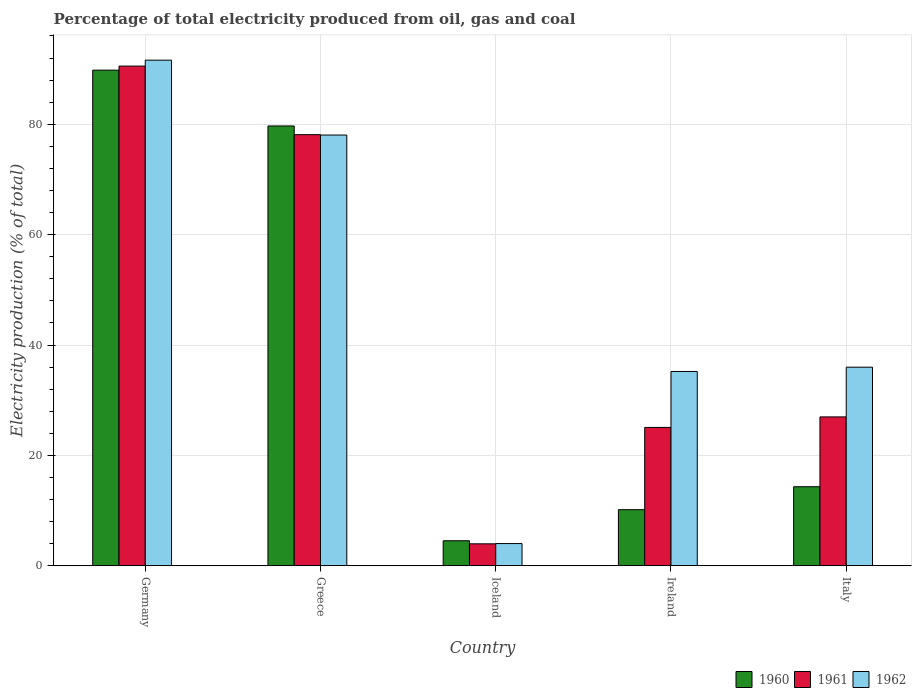Are the number of bars on each tick of the X-axis equal?
Ensure brevity in your answer.  Yes. How many bars are there on the 2nd tick from the left?
Ensure brevity in your answer.  3. How many bars are there on the 4th tick from the right?
Offer a terse response. 3. What is the label of the 3rd group of bars from the left?
Offer a terse response. Iceland. What is the electricity production in in 1961 in Ireland?
Your response must be concise. 25.07. Across all countries, what is the maximum electricity production in in 1961?
Offer a terse response. 90.54. Across all countries, what is the minimum electricity production in in 1960?
Provide a succinct answer. 4.54. In which country was the electricity production in in 1961 maximum?
Provide a succinct answer. Germany. What is the total electricity production in in 1961 in the graph?
Provide a short and direct response. 224.69. What is the difference between the electricity production in in 1960 in Germany and that in Iceland?
Offer a very short reply. 85.27. What is the difference between the electricity production in in 1962 in Ireland and the electricity production in in 1961 in Germany?
Ensure brevity in your answer.  -55.33. What is the average electricity production in in 1962 per country?
Your response must be concise. 48.98. What is the difference between the electricity production in of/in 1960 and electricity production in of/in 1961 in Ireland?
Your answer should be compact. -14.9. In how many countries, is the electricity production in in 1961 greater than 44 %?
Ensure brevity in your answer.  2. What is the ratio of the electricity production in in 1960 in Iceland to that in Italy?
Your answer should be very brief. 0.32. What is the difference between the highest and the second highest electricity production in in 1960?
Give a very brief answer. 75.48. What is the difference between the highest and the lowest electricity production in in 1962?
Your answer should be very brief. 87.59. What does the 3rd bar from the left in Germany represents?
Your answer should be compact. 1962. How many bars are there?
Your answer should be compact. 15. Are all the bars in the graph horizontal?
Provide a short and direct response. No. What is the difference between two consecutive major ticks on the Y-axis?
Keep it short and to the point. 20. Does the graph contain any zero values?
Your answer should be very brief. No. Does the graph contain grids?
Keep it short and to the point. Yes. Where does the legend appear in the graph?
Provide a short and direct response. Bottom right. How many legend labels are there?
Keep it short and to the point. 3. How are the legend labels stacked?
Provide a succinct answer. Horizontal. What is the title of the graph?
Provide a succinct answer. Percentage of total electricity produced from oil, gas and coal. What is the label or title of the Y-axis?
Offer a very short reply. Electricity production (% of total). What is the Electricity production (% of total) in 1960 in Germany?
Offer a very short reply. 89.81. What is the Electricity production (% of total) of 1961 in Germany?
Offer a terse response. 90.54. What is the Electricity production (% of total) in 1962 in Germany?
Give a very brief answer. 91.62. What is the Electricity production (% of total) of 1960 in Greece?
Offer a terse response. 79.69. What is the Electricity production (% of total) in 1961 in Greece?
Keep it short and to the point. 78.12. What is the Electricity production (% of total) of 1962 in Greece?
Give a very brief answer. 78.05. What is the Electricity production (% of total) in 1960 in Iceland?
Offer a very short reply. 4.54. What is the Electricity production (% of total) of 1961 in Iceland?
Offer a terse response. 3.98. What is the Electricity production (% of total) of 1962 in Iceland?
Make the answer very short. 4.03. What is the Electricity production (% of total) of 1960 in Ireland?
Keep it short and to the point. 10.17. What is the Electricity production (% of total) of 1961 in Ireland?
Your answer should be compact. 25.07. What is the Electricity production (% of total) of 1962 in Ireland?
Give a very brief answer. 35.21. What is the Electricity production (% of total) in 1960 in Italy?
Offer a very short reply. 14.33. What is the Electricity production (% of total) in 1961 in Italy?
Keep it short and to the point. 26.98. What is the Electricity production (% of total) of 1962 in Italy?
Offer a terse response. 35.99. Across all countries, what is the maximum Electricity production (% of total) in 1960?
Provide a succinct answer. 89.81. Across all countries, what is the maximum Electricity production (% of total) in 1961?
Offer a very short reply. 90.54. Across all countries, what is the maximum Electricity production (% of total) in 1962?
Ensure brevity in your answer.  91.62. Across all countries, what is the minimum Electricity production (% of total) in 1960?
Your response must be concise. 4.54. Across all countries, what is the minimum Electricity production (% of total) in 1961?
Make the answer very short. 3.98. Across all countries, what is the minimum Electricity production (% of total) of 1962?
Your response must be concise. 4.03. What is the total Electricity production (% of total) of 1960 in the graph?
Provide a short and direct response. 198.53. What is the total Electricity production (% of total) in 1961 in the graph?
Give a very brief answer. 224.69. What is the total Electricity production (% of total) of 1962 in the graph?
Your answer should be very brief. 244.89. What is the difference between the Electricity production (% of total) of 1960 in Germany and that in Greece?
Offer a terse response. 10.11. What is the difference between the Electricity production (% of total) of 1961 in Germany and that in Greece?
Provide a succinct answer. 12.43. What is the difference between the Electricity production (% of total) of 1962 in Germany and that in Greece?
Your response must be concise. 13.57. What is the difference between the Electricity production (% of total) of 1960 in Germany and that in Iceland?
Your response must be concise. 85.27. What is the difference between the Electricity production (% of total) of 1961 in Germany and that in Iceland?
Ensure brevity in your answer.  86.56. What is the difference between the Electricity production (% of total) in 1962 in Germany and that in Iceland?
Offer a very short reply. 87.59. What is the difference between the Electricity production (% of total) in 1960 in Germany and that in Ireland?
Your answer should be very brief. 79.64. What is the difference between the Electricity production (% of total) of 1961 in Germany and that in Ireland?
Your answer should be compact. 65.47. What is the difference between the Electricity production (% of total) in 1962 in Germany and that in Ireland?
Ensure brevity in your answer.  56.41. What is the difference between the Electricity production (% of total) in 1960 in Germany and that in Italy?
Your answer should be compact. 75.48. What is the difference between the Electricity production (% of total) in 1961 in Germany and that in Italy?
Keep it short and to the point. 63.57. What is the difference between the Electricity production (% of total) in 1962 in Germany and that in Italy?
Provide a short and direct response. 55.63. What is the difference between the Electricity production (% of total) of 1960 in Greece and that in Iceland?
Make the answer very short. 75.16. What is the difference between the Electricity production (% of total) of 1961 in Greece and that in Iceland?
Provide a short and direct response. 74.14. What is the difference between the Electricity production (% of total) of 1962 in Greece and that in Iceland?
Offer a terse response. 74.02. What is the difference between the Electricity production (% of total) in 1960 in Greece and that in Ireland?
Give a very brief answer. 69.53. What is the difference between the Electricity production (% of total) in 1961 in Greece and that in Ireland?
Your answer should be very brief. 53.05. What is the difference between the Electricity production (% of total) in 1962 in Greece and that in Ireland?
Keep it short and to the point. 42.84. What is the difference between the Electricity production (% of total) in 1960 in Greece and that in Italy?
Keep it short and to the point. 65.37. What is the difference between the Electricity production (% of total) of 1961 in Greece and that in Italy?
Give a very brief answer. 51.14. What is the difference between the Electricity production (% of total) of 1962 in Greece and that in Italy?
Ensure brevity in your answer.  42.06. What is the difference between the Electricity production (% of total) of 1960 in Iceland and that in Ireland?
Provide a succinct answer. -5.63. What is the difference between the Electricity production (% of total) of 1961 in Iceland and that in Ireland?
Your answer should be compact. -21.09. What is the difference between the Electricity production (% of total) of 1962 in Iceland and that in Ireland?
Keep it short and to the point. -31.19. What is the difference between the Electricity production (% of total) in 1960 in Iceland and that in Italy?
Provide a short and direct response. -9.79. What is the difference between the Electricity production (% of total) of 1961 in Iceland and that in Italy?
Your answer should be compact. -23. What is the difference between the Electricity production (% of total) of 1962 in Iceland and that in Italy?
Ensure brevity in your answer.  -31.96. What is the difference between the Electricity production (% of total) of 1960 in Ireland and that in Italy?
Your response must be concise. -4.16. What is the difference between the Electricity production (% of total) of 1961 in Ireland and that in Italy?
Your answer should be compact. -1.91. What is the difference between the Electricity production (% of total) in 1962 in Ireland and that in Italy?
Provide a short and direct response. -0.78. What is the difference between the Electricity production (% of total) of 1960 in Germany and the Electricity production (% of total) of 1961 in Greece?
Ensure brevity in your answer.  11.69. What is the difference between the Electricity production (% of total) of 1960 in Germany and the Electricity production (% of total) of 1962 in Greece?
Offer a very short reply. 11.76. What is the difference between the Electricity production (% of total) in 1961 in Germany and the Electricity production (% of total) in 1962 in Greece?
Your answer should be compact. 12.49. What is the difference between the Electricity production (% of total) of 1960 in Germany and the Electricity production (% of total) of 1961 in Iceland?
Make the answer very short. 85.83. What is the difference between the Electricity production (% of total) in 1960 in Germany and the Electricity production (% of total) in 1962 in Iceland?
Your response must be concise. 85.78. What is the difference between the Electricity production (% of total) of 1961 in Germany and the Electricity production (% of total) of 1962 in Iceland?
Offer a terse response. 86.52. What is the difference between the Electricity production (% of total) in 1960 in Germany and the Electricity production (% of total) in 1961 in Ireland?
Provide a short and direct response. 64.74. What is the difference between the Electricity production (% of total) of 1960 in Germany and the Electricity production (% of total) of 1962 in Ireland?
Provide a succinct answer. 54.6. What is the difference between the Electricity production (% of total) in 1961 in Germany and the Electricity production (% of total) in 1962 in Ireland?
Provide a succinct answer. 55.33. What is the difference between the Electricity production (% of total) in 1960 in Germany and the Electricity production (% of total) in 1961 in Italy?
Make the answer very short. 62.83. What is the difference between the Electricity production (% of total) in 1960 in Germany and the Electricity production (% of total) in 1962 in Italy?
Your answer should be compact. 53.82. What is the difference between the Electricity production (% of total) in 1961 in Germany and the Electricity production (% of total) in 1962 in Italy?
Offer a very short reply. 54.56. What is the difference between the Electricity production (% of total) of 1960 in Greece and the Electricity production (% of total) of 1961 in Iceland?
Give a very brief answer. 75.71. What is the difference between the Electricity production (% of total) of 1960 in Greece and the Electricity production (% of total) of 1962 in Iceland?
Your answer should be compact. 75.67. What is the difference between the Electricity production (% of total) of 1961 in Greece and the Electricity production (% of total) of 1962 in Iceland?
Make the answer very short. 74.09. What is the difference between the Electricity production (% of total) in 1960 in Greece and the Electricity production (% of total) in 1961 in Ireland?
Your answer should be very brief. 54.62. What is the difference between the Electricity production (% of total) in 1960 in Greece and the Electricity production (% of total) in 1962 in Ireland?
Provide a succinct answer. 44.48. What is the difference between the Electricity production (% of total) of 1961 in Greece and the Electricity production (% of total) of 1962 in Ireland?
Your response must be concise. 42.91. What is the difference between the Electricity production (% of total) of 1960 in Greece and the Electricity production (% of total) of 1961 in Italy?
Provide a short and direct response. 52.72. What is the difference between the Electricity production (% of total) in 1960 in Greece and the Electricity production (% of total) in 1962 in Italy?
Your answer should be compact. 43.71. What is the difference between the Electricity production (% of total) of 1961 in Greece and the Electricity production (% of total) of 1962 in Italy?
Give a very brief answer. 42.13. What is the difference between the Electricity production (% of total) in 1960 in Iceland and the Electricity production (% of total) in 1961 in Ireland?
Offer a terse response. -20.53. What is the difference between the Electricity production (% of total) in 1960 in Iceland and the Electricity production (% of total) in 1962 in Ireland?
Make the answer very short. -30.67. What is the difference between the Electricity production (% of total) of 1961 in Iceland and the Electricity production (% of total) of 1962 in Ireland?
Provide a short and direct response. -31.23. What is the difference between the Electricity production (% of total) in 1960 in Iceland and the Electricity production (% of total) in 1961 in Italy?
Offer a terse response. -22.44. What is the difference between the Electricity production (% of total) of 1960 in Iceland and the Electricity production (% of total) of 1962 in Italy?
Give a very brief answer. -31.45. What is the difference between the Electricity production (% of total) in 1961 in Iceland and the Electricity production (% of total) in 1962 in Italy?
Your answer should be very brief. -32.01. What is the difference between the Electricity production (% of total) in 1960 in Ireland and the Electricity production (% of total) in 1961 in Italy?
Provide a succinct answer. -16.81. What is the difference between the Electricity production (% of total) of 1960 in Ireland and the Electricity production (% of total) of 1962 in Italy?
Make the answer very short. -25.82. What is the difference between the Electricity production (% of total) in 1961 in Ireland and the Electricity production (% of total) in 1962 in Italy?
Make the answer very short. -10.92. What is the average Electricity production (% of total) in 1960 per country?
Keep it short and to the point. 39.71. What is the average Electricity production (% of total) in 1961 per country?
Offer a very short reply. 44.94. What is the average Electricity production (% of total) in 1962 per country?
Provide a succinct answer. 48.98. What is the difference between the Electricity production (% of total) in 1960 and Electricity production (% of total) in 1961 in Germany?
Provide a succinct answer. -0.74. What is the difference between the Electricity production (% of total) of 1960 and Electricity production (% of total) of 1962 in Germany?
Offer a terse response. -1.81. What is the difference between the Electricity production (% of total) in 1961 and Electricity production (% of total) in 1962 in Germany?
Give a very brief answer. -1.07. What is the difference between the Electricity production (% of total) of 1960 and Electricity production (% of total) of 1961 in Greece?
Provide a short and direct response. 1.58. What is the difference between the Electricity production (% of total) in 1960 and Electricity production (% of total) in 1962 in Greece?
Give a very brief answer. 1.64. What is the difference between the Electricity production (% of total) of 1961 and Electricity production (% of total) of 1962 in Greece?
Make the answer very short. 0.07. What is the difference between the Electricity production (% of total) of 1960 and Electricity production (% of total) of 1961 in Iceland?
Your answer should be compact. 0.56. What is the difference between the Electricity production (% of total) of 1960 and Electricity production (% of total) of 1962 in Iceland?
Your answer should be compact. 0.51. What is the difference between the Electricity production (% of total) of 1961 and Electricity production (% of total) of 1962 in Iceland?
Offer a terse response. -0.05. What is the difference between the Electricity production (% of total) in 1960 and Electricity production (% of total) in 1961 in Ireland?
Offer a very short reply. -14.9. What is the difference between the Electricity production (% of total) of 1960 and Electricity production (% of total) of 1962 in Ireland?
Keep it short and to the point. -25.04. What is the difference between the Electricity production (% of total) of 1961 and Electricity production (% of total) of 1962 in Ireland?
Give a very brief answer. -10.14. What is the difference between the Electricity production (% of total) in 1960 and Electricity production (% of total) in 1961 in Italy?
Your response must be concise. -12.65. What is the difference between the Electricity production (% of total) in 1960 and Electricity production (% of total) in 1962 in Italy?
Keep it short and to the point. -21.66. What is the difference between the Electricity production (% of total) in 1961 and Electricity production (% of total) in 1962 in Italy?
Give a very brief answer. -9.01. What is the ratio of the Electricity production (% of total) in 1960 in Germany to that in Greece?
Offer a terse response. 1.13. What is the ratio of the Electricity production (% of total) in 1961 in Germany to that in Greece?
Provide a succinct answer. 1.16. What is the ratio of the Electricity production (% of total) in 1962 in Germany to that in Greece?
Make the answer very short. 1.17. What is the ratio of the Electricity production (% of total) in 1960 in Germany to that in Iceland?
Offer a very short reply. 19.79. What is the ratio of the Electricity production (% of total) of 1961 in Germany to that in Iceland?
Make the answer very short. 22.75. What is the ratio of the Electricity production (% of total) of 1962 in Germany to that in Iceland?
Provide a succinct answer. 22.76. What is the ratio of the Electricity production (% of total) in 1960 in Germany to that in Ireland?
Your answer should be compact. 8.83. What is the ratio of the Electricity production (% of total) of 1961 in Germany to that in Ireland?
Give a very brief answer. 3.61. What is the ratio of the Electricity production (% of total) in 1962 in Germany to that in Ireland?
Provide a short and direct response. 2.6. What is the ratio of the Electricity production (% of total) of 1960 in Germany to that in Italy?
Offer a very short reply. 6.27. What is the ratio of the Electricity production (% of total) in 1961 in Germany to that in Italy?
Offer a very short reply. 3.36. What is the ratio of the Electricity production (% of total) in 1962 in Germany to that in Italy?
Your answer should be compact. 2.55. What is the ratio of the Electricity production (% of total) in 1960 in Greece to that in Iceland?
Your answer should be very brief. 17.56. What is the ratio of the Electricity production (% of total) of 1961 in Greece to that in Iceland?
Ensure brevity in your answer.  19.63. What is the ratio of the Electricity production (% of total) in 1962 in Greece to that in Iceland?
Offer a very short reply. 19.39. What is the ratio of the Electricity production (% of total) in 1960 in Greece to that in Ireland?
Your answer should be compact. 7.84. What is the ratio of the Electricity production (% of total) in 1961 in Greece to that in Ireland?
Make the answer very short. 3.12. What is the ratio of the Electricity production (% of total) of 1962 in Greece to that in Ireland?
Your answer should be very brief. 2.22. What is the ratio of the Electricity production (% of total) of 1960 in Greece to that in Italy?
Provide a succinct answer. 5.56. What is the ratio of the Electricity production (% of total) of 1961 in Greece to that in Italy?
Give a very brief answer. 2.9. What is the ratio of the Electricity production (% of total) in 1962 in Greece to that in Italy?
Your answer should be very brief. 2.17. What is the ratio of the Electricity production (% of total) of 1960 in Iceland to that in Ireland?
Provide a succinct answer. 0.45. What is the ratio of the Electricity production (% of total) of 1961 in Iceland to that in Ireland?
Provide a short and direct response. 0.16. What is the ratio of the Electricity production (% of total) of 1962 in Iceland to that in Ireland?
Your response must be concise. 0.11. What is the ratio of the Electricity production (% of total) in 1960 in Iceland to that in Italy?
Your response must be concise. 0.32. What is the ratio of the Electricity production (% of total) of 1961 in Iceland to that in Italy?
Make the answer very short. 0.15. What is the ratio of the Electricity production (% of total) of 1962 in Iceland to that in Italy?
Provide a succinct answer. 0.11. What is the ratio of the Electricity production (% of total) in 1960 in Ireland to that in Italy?
Provide a succinct answer. 0.71. What is the ratio of the Electricity production (% of total) in 1961 in Ireland to that in Italy?
Ensure brevity in your answer.  0.93. What is the ratio of the Electricity production (% of total) of 1962 in Ireland to that in Italy?
Your answer should be compact. 0.98. What is the difference between the highest and the second highest Electricity production (% of total) in 1960?
Your response must be concise. 10.11. What is the difference between the highest and the second highest Electricity production (% of total) of 1961?
Your answer should be compact. 12.43. What is the difference between the highest and the second highest Electricity production (% of total) in 1962?
Your response must be concise. 13.57. What is the difference between the highest and the lowest Electricity production (% of total) in 1960?
Keep it short and to the point. 85.27. What is the difference between the highest and the lowest Electricity production (% of total) of 1961?
Your response must be concise. 86.56. What is the difference between the highest and the lowest Electricity production (% of total) in 1962?
Make the answer very short. 87.59. 